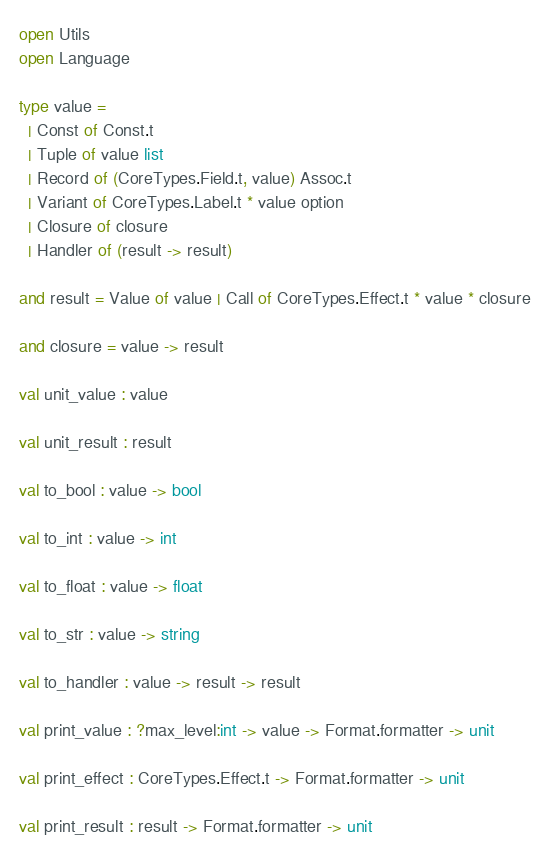<code> <loc_0><loc_0><loc_500><loc_500><_OCaml_>open Utils
open Language

type value =
  | Const of Const.t
  | Tuple of value list
  | Record of (CoreTypes.Field.t, value) Assoc.t
  | Variant of CoreTypes.Label.t * value option
  | Closure of closure
  | Handler of (result -> result)

and result = Value of value | Call of CoreTypes.Effect.t * value * closure

and closure = value -> result

val unit_value : value

val unit_result : result

val to_bool : value -> bool

val to_int : value -> int

val to_float : value -> float

val to_str : value -> string

val to_handler : value -> result -> result

val print_value : ?max_level:int -> value -> Format.formatter -> unit

val print_effect : CoreTypes.Effect.t -> Format.formatter -> unit

val print_result : result -> Format.formatter -> unit
</code> 